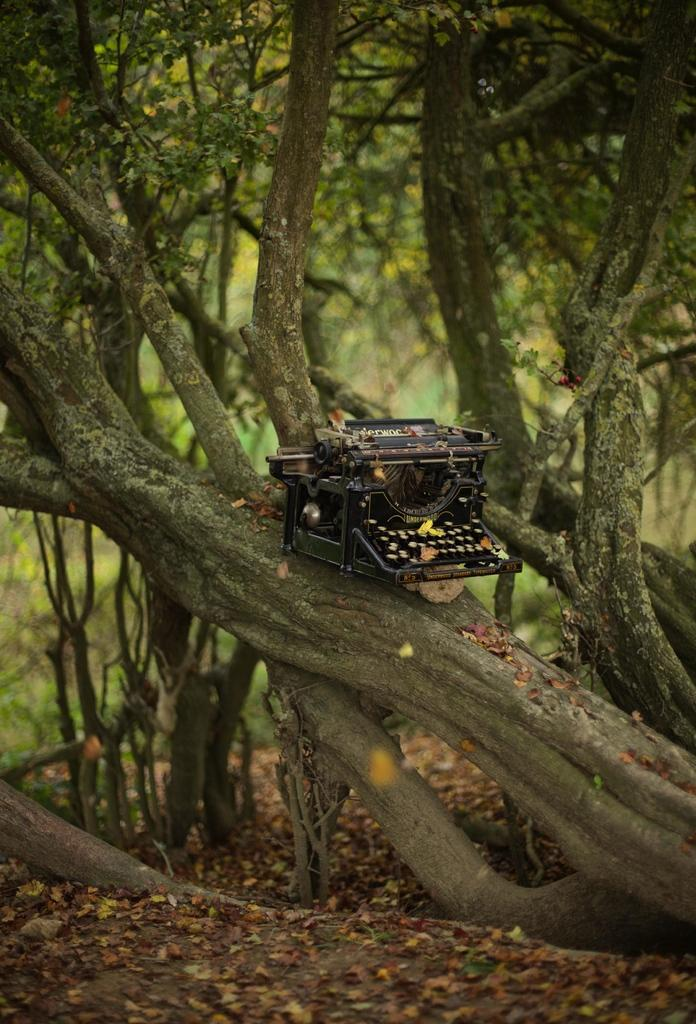What is the color of the object on the branch in the image? The object is black in color. Where is the object located in the image? The object is on the branch of a tree. What can be seen in the background of the image? There are many trees visible in the background of the image. What is the opinion of the donkey about the object on the branch in the image? There is no donkey present in the image, so it is not possible to determine its opinion about the object on the branch. 